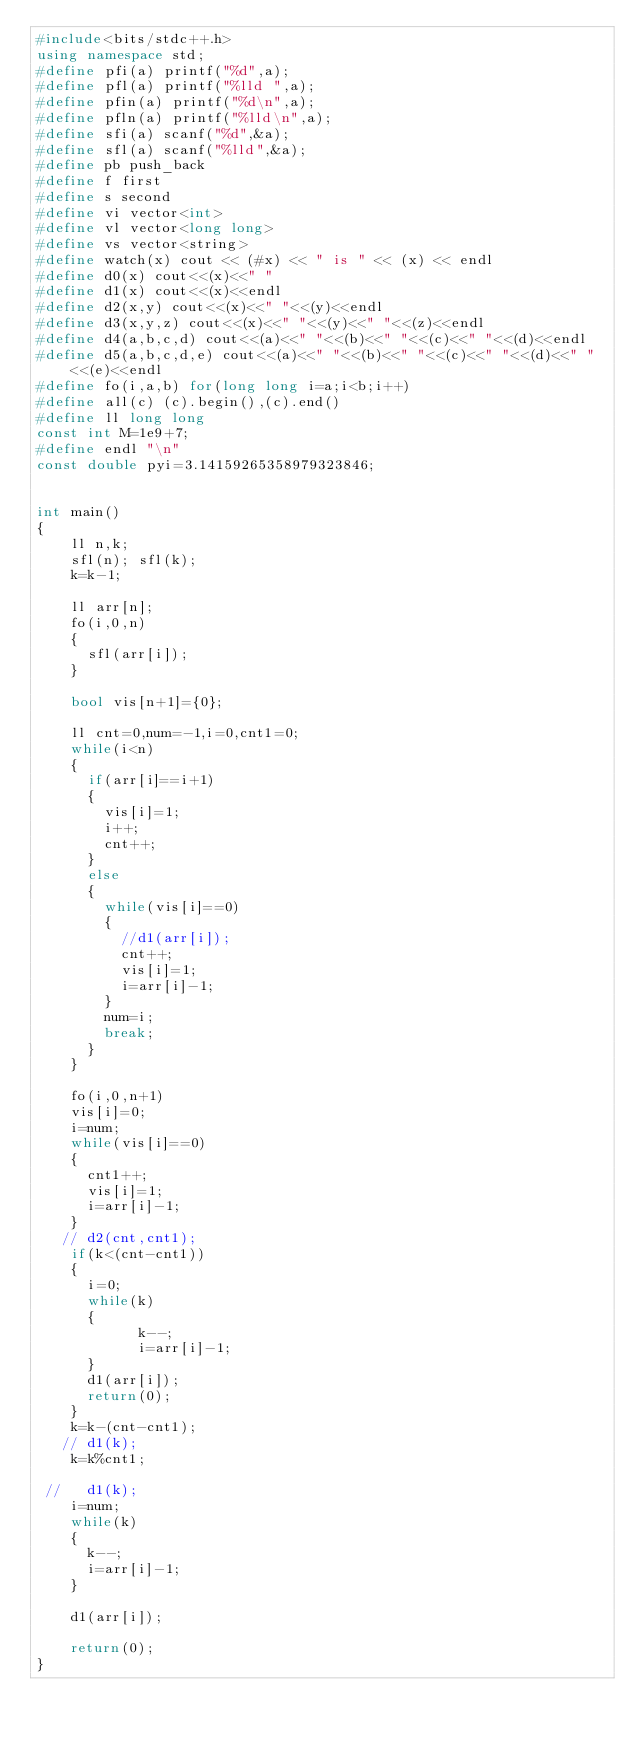<code> <loc_0><loc_0><loc_500><loc_500><_C++_>#include<bits/stdc++.h>
using namespace std;
#define pfi(a) printf("%d",a);
#define pfl(a) printf("%lld ",a);
#define pfin(a) printf("%d\n",a);
#define pfln(a) printf("%lld\n",a);
#define sfi(a) scanf("%d",&a);
#define sfl(a) scanf("%lld",&a);
#define pb push_back
#define f first
#define s second
#define vi vector<int>
#define vl vector<long long>
#define vs vector<string>
#define watch(x) cout << (#x) << " is " << (x) << endl
#define d0(x) cout<<(x)<<" "
#define d1(x) cout<<(x)<<endl
#define d2(x,y) cout<<(x)<<" "<<(y)<<endl
#define d3(x,y,z) cout<<(x)<<" "<<(y)<<" "<<(z)<<endl
#define d4(a,b,c,d) cout<<(a)<<" "<<(b)<<" "<<(c)<<" "<<(d)<<endl
#define d5(a,b,c,d,e) cout<<(a)<<" "<<(b)<<" "<<(c)<<" "<<(d)<<" "<<(e)<<endl
#define fo(i,a,b) for(long long i=a;i<b;i++)
#define all(c) (c).begin(),(c).end()
#define ll long long
const int M=1e9+7;
#define endl "\n"
const double pyi=3.14159265358979323846;


int main() 
{ 
    ll n,k;
    sfl(n); sfl(k);
    k=k-1;

    ll arr[n];
    fo(i,0,n)
    {
    	sfl(arr[i]);
    }

    bool vis[n+1]={0};

    ll cnt=0,num=-1,i=0,cnt1=0;
    while(i<n)
    {
    	if(arr[i]==i+1)
    	{
    		vis[i]=1;
    		i++;
    		cnt++;
    	}
    	else
    	{
    		while(vis[i]==0)
    		{
    			//d1(arr[i]);
    			cnt++;
    			vis[i]=1;
    			i=arr[i]-1;
    		}
    		num=i;
    		break;
    	}
    }

    fo(i,0,n+1)
    vis[i]=0;
    i=num;
    while(vis[i]==0)
    {
    	cnt1++;
    	vis[i]=1;
    	i=arr[i]-1;
    }
   // d2(cnt,cnt1);
    if(k<(cnt-cnt1))
    {
    	i=0;
    	while(k)
    	{
            k--;
            i=arr[i]-1;
    	}
    	d1(arr[i]);
    	return(0);
    }
    k=k-(cnt-cnt1);
   // d1(k);
    k=k%cnt1;

 //   d1(k);
    i=num;
    while(k)
    {
    	k--;
    	i=arr[i]-1;
    }

    d1(arr[i]);
    
    return(0);
}</code> 